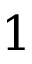<formula> <loc_0><loc_0><loc_500><loc_500>1</formula> 